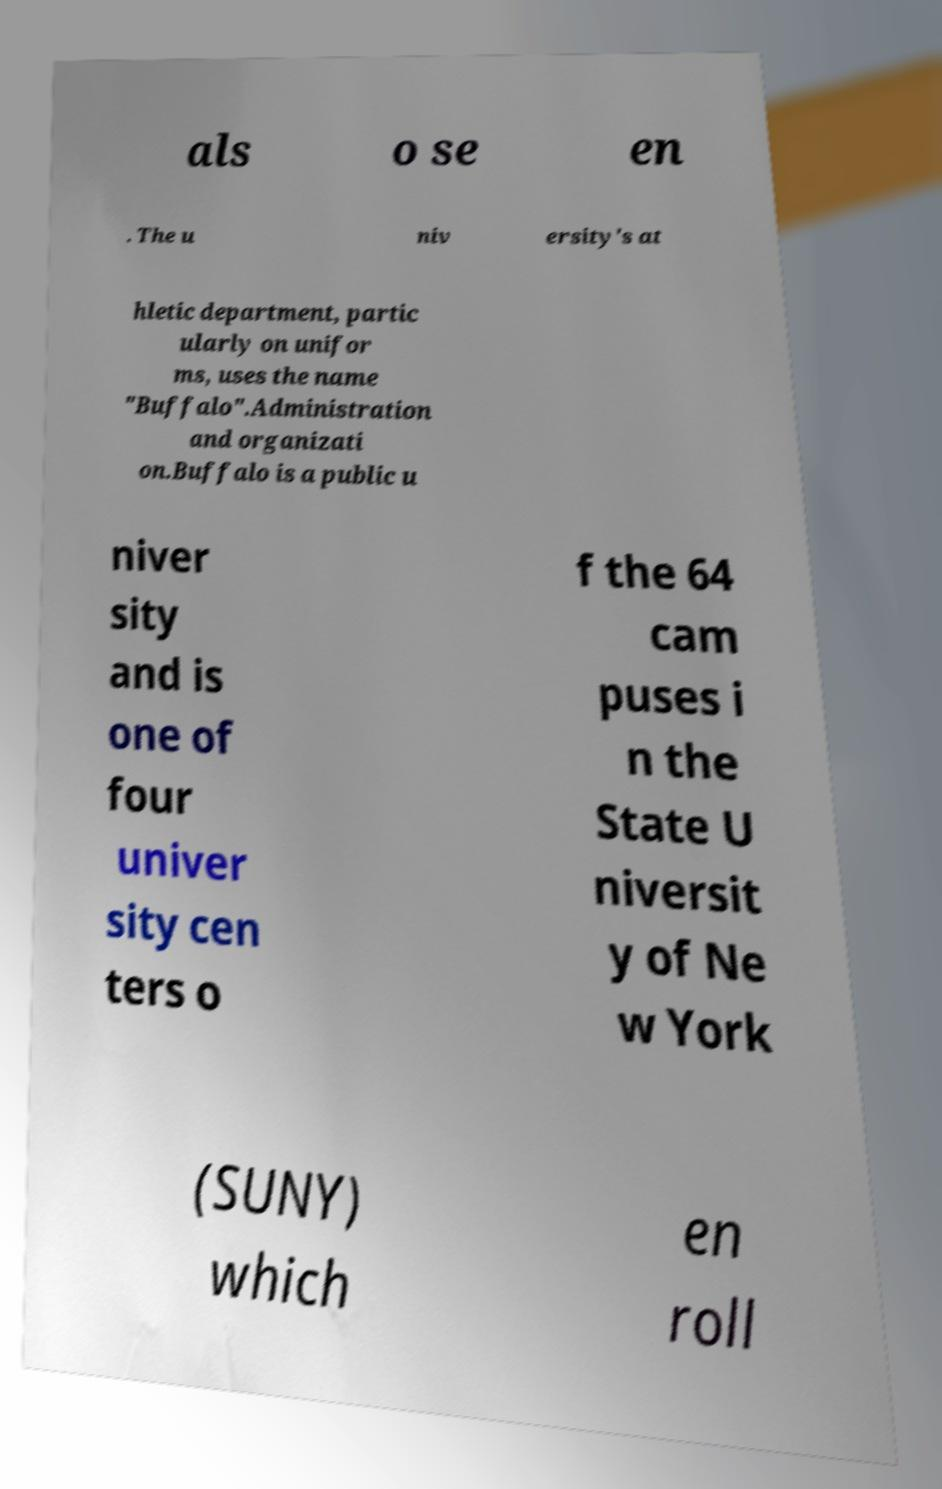Could you extract and type out the text from this image? als o se en . The u niv ersity's at hletic department, partic ularly on unifor ms, uses the name "Buffalo".Administration and organizati on.Buffalo is a public u niver sity and is one of four univer sity cen ters o f the 64 cam puses i n the State U niversit y of Ne w York (SUNY) which en roll 